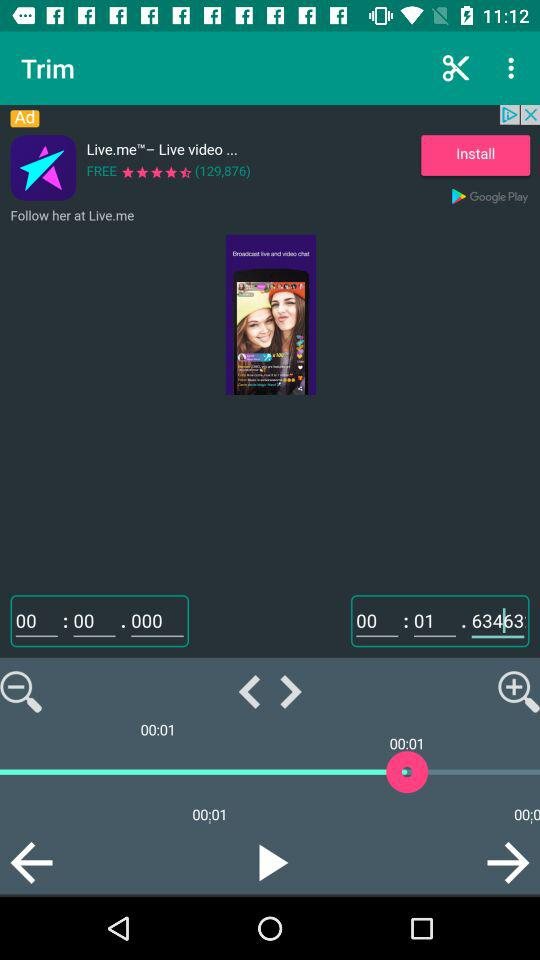How many people rated the application? The number of people who have rated the application is 129,876. 